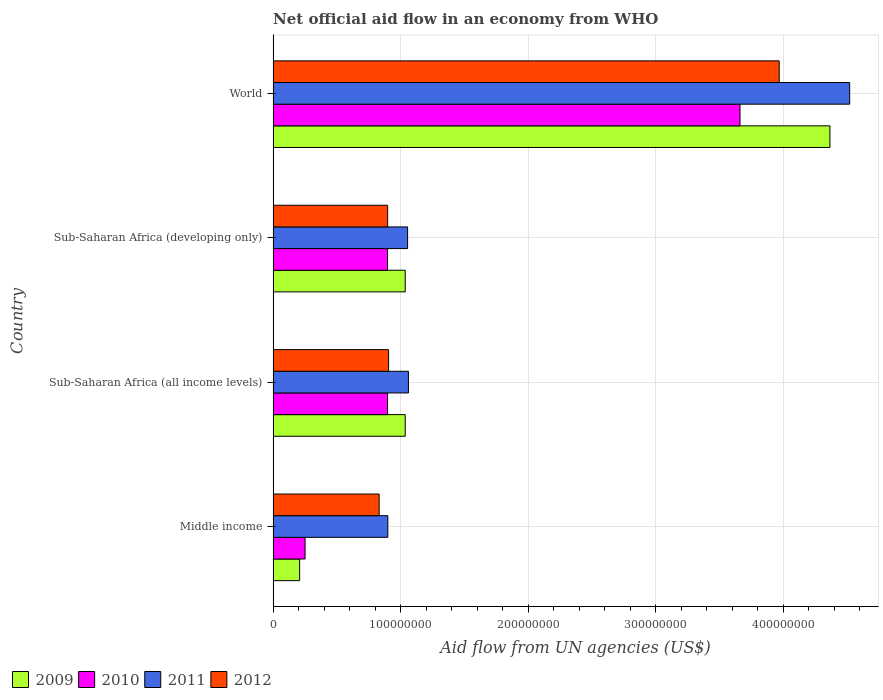How many groups of bars are there?
Ensure brevity in your answer.  4. How many bars are there on the 2nd tick from the top?
Make the answer very short. 4. What is the label of the 3rd group of bars from the top?
Your answer should be very brief. Sub-Saharan Africa (all income levels). What is the net official aid flow in 2010 in Sub-Saharan Africa (developing only)?
Your answer should be very brief. 8.98e+07. Across all countries, what is the maximum net official aid flow in 2010?
Provide a succinct answer. 3.66e+08. Across all countries, what is the minimum net official aid flow in 2011?
Make the answer very short. 9.00e+07. In which country was the net official aid flow in 2011 maximum?
Offer a terse response. World. In which country was the net official aid flow in 2011 minimum?
Provide a succinct answer. Middle income. What is the total net official aid flow in 2010 in the graph?
Offer a very short reply. 5.71e+08. What is the difference between the net official aid flow in 2009 in Sub-Saharan Africa (developing only) and that in World?
Ensure brevity in your answer.  -3.33e+08. What is the difference between the net official aid flow in 2010 in Sub-Saharan Africa (all income levels) and the net official aid flow in 2012 in Middle income?
Your answer should be compact. 6.58e+06. What is the average net official aid flow in 2009 per country?
Offer a very short reply. 1.66e+08. What is the difference between the net official aid flow in 2009 and net official aid flow in 2011 in Sub-Saharan Africa (all income levels)?
Your answer should be compact. -2.53e+06. Is the difference between the net official aid flow in 2009 in Sub-Saharan Africa (all income levels) and World greater than the difference between the net official aid flow in 2011 in Sub-Saharan Africa (all income levels) and World?
Provide a short and direct response. Yes. What is the difference between the highest and the second highest net official aid flow in 2011?
Provide a short and direct response. 3.46e+08. What is the difference between the highest and the lowest net official aid flow in 2009?
Keep it short and to the point. 4.16e+08. Is the sum of the net official aid flow in 2012 in Sub-Saharan Africa (all income levels) and World greater than the maximum net official aid flow in 2011 across all countries?
Make the answer very short. Yes. What does the 4th bar from the bottom in Sub-Saharan Africa (developing only) represents?
Give a very brief answer. 2012. Are all the bars in the graph horizontal?
Provide a short and direct response. Yes. How many countries are there in the graph?
Your answer should be very brief. 4. Where does the legend appear in the graph?
Offer a terse response. Bottom left. What is the title of the graph?
Ensure brevity in your answer.  Net official aid flow in an economy from WHO. Does "1964" appear as one of the legend labels in the graph?
Provide a short and direct response. No. What is the label or title of the X-axis?
Your answer should be very brief. Aid flow from UN agencies (US$). What is the Aid flow from UN agencies (US$) in 2009 in Middle income?
Keep it short and to the point. 2.08e+07. What is the Aid flow from UN agencies (US$) in 2010 in Middle income?
Your response must be concise. 2.51e+07. What is the Aid flow from UN agencies (US$) in 2011 in Middle income?
Provide a short and direct response. 9.00e+07. What is the Aid flow from UN agencies (US$) of 2012 in Middle income?
Your response must be concise. 8.32e+07. What is the Aid flow from UN agencies (US$) of 2009 in Sub-Saharan Africa (all income levels)?
Offer a terse response. 1.04e+08. What is the Aid flow from UN agencies (US$) in 2010 in Sub-Saharan Africa (all income levels)?
Give a very brief answer. 8.98e+07. What is the Aid flow from UN agencies (US$) in 2011 in Sub-Saharan Africa (all income levels)?
Your answer should be very brief. 1.06e+08. What is the Aid flow from UN agencies (US$) in 2012 in Sub-Saharan Africa (all income levels)?
Make the answer very short. 9.06e+07. What is the Aid flow from UN agencies (US$) in 2009 in Sub-Saharan Africa (developing only)?
Offer a very short reply. 1.04e+08. What is the Aid flow from UN agencies (US$) of 2010 in Sub-Saharan Africa (developing only)?
Provide a succinct answer. 8.98e+07. What is the Aid flow from UN agencies (US$) of 2011 in Sub-Saharan Africa (developing only)?
Your response must be concise. 1.05e+08. What is the Aid flow from UN agencies (US$) in 2012 in Sub-Saharan Africa (developing only)?
Your answer should be compact. 8.98e+07. What is the Aid flow from UN agencies (US$) of 2009 in World?
Your response must be concise. 4.37e+08. What is the Aid flow from UN agencies (US$) in 2010 in World?
Your answer should be compact. 3.66e+08. What is the Aid flow from UN agencies (US$) in 2011 in World?
Provide a succinct answer. 4.52e+08. What is the Aid flow from UN agencies (US$) in 2012 in World?
Offer a very short reply. 3.97e+08. Across all countries, what is the maximum Aid flow from UN agencies (US$) of 2009?
Provide a succinct answer. 4.37e+08. Across all countries, what is the maximum Aid flow from UN agencies (US$) of 2010?
Your answer should be compact. 3.66e+08. Across all countries, what is the maximum Aid flow from UN agencies (US$) of 2011?
Keep it short and to the point. 4.52e+08. Across all countries, what is the maximum Aid flow from UN agencies (US$) in 2012?
Ensure brevity in your answer.  3.97e+08. Across all countries, what is the minimum Aid flow from UN agencies (US$) in 2009?
Your answer should be compact. 2.08e+07. Across all countries, what is the minimum Aid flow from UN agencies (US$) in 2010?
Keep it short and to the point. 2.51e+07. Across all countries, what is the minimum Aid flow from UN agencies (US$) of 2011?
Provide a succinct answer. 9.00e+07. Across all countries, what is the minimum Aid flow from UN agencies (US$) in 2012?
Offer a terse response. 8.32e+07. What is the total Aid flow from UN agencies (US$) in 2009 in the graph?
Keep it short and to the point. 6.65e+08. What is the total Aid flow from UN agencies (US$) in 2010 in the graph?
Offer a terse response. 5.71e+08. What is the total Aid flow from UN agencies (US$) in 2011 in the graph?
Your answer should be compact. 7.54e+08. What is the total Aid flow from UN agencies (US$) of 2012 in the graph?
Provide a succinct answer. 6.61e+08. What is the difference between the Aid flow from UN agencies (US$) of 2009 in Middle income and that in Sub-Saharan Africa (all income levels)?
Offer a very short reply. -8.28e+07. What is the difference between the Aid flow from UN agencies (US$) of 2010 in Middle income and that in Sub-Saharan Africa (all income levels)?
Your answer should be very brief. -6.47e+07. What is the difference between the Aid flow from UN agencies (US$) of 2011 in Middle income and that in Sub-Saharan Africa (all income levels)?
Make the answer very short. -1.62e+07. What is the difference between the Aid flow from UN agencies (US$) of 2012 in Middle income and that in Sub-Saharan Africa (all income levels)?
Keep it short and to the point. -7.39e+06. What is the difference between the Aid flow from UN agencies (US$) in 2009 in Middle income and that in Sub-Saharan Africa (developing only)?
Offer a terse response. -8.28e+07. What is the difference between the Aid flow from UN agencies (US$) in 2010 in Middle income and that in Sub-Saharan Africa (developing only)?
Give a very brief answer. -6.47e+07. What is the difference between the Aid flow from UN agencies (US$) in 2011 in Middle income and that in Sub-Saharan Africa (developing only)?
Offer a very short reply. -1.55e+07. What is the difference between the Aid flow from UN agencies (US$) of 2012 in Middle income and that in Sub-Saharan Africa (developing only)?
Provide a short and direct response. -6.67e+06. What is the difference between the Aid flow from UN agencies (US$) in 2009 in Middle income and that in World?
Give a very brief answer. -4.16e+08. What is the difference between the Aid flow from UN agencies (US$) in 2010 in Middle income and that in World?
Provide a short and direct response. -3.41e+08. What is the difference between the Aid flow from UN agencies (US$) in 2011 in Middle income and that in World?
Your response must be concise. -3.62e+08. What is the difference between the Aid flow from UN agencies (US$) of 2012 in Middle income and that in World?
Offer a terse response. -3.14e+08. What is the difference between the Aid flow from UN agencies (US$) in 2010 in Sub-Saharan Africa (all income levels) and that in Sub-Saharan Africa (developing only)?
Offer a terse response. 0. What is the difference between the Aid flow from UN agencies (US$) of 2011 in Sub-Saharan Africa (all income levels) and that in Sub-Saharan Africa (developing only)?
Make the answer very short. 6.70e+05. What is the difference between the Aid flow from UN agencies (US$) of 2012 in Sub-Saharan Africa (all income levels) and that in Sub-Saharan Africa (developing only)?
Provide a short and direct response. 7.20e+05. What is the difference between the Aid flow from UN agencies (US$) of 2009 in Sub-Saharan Africa (all income levels) and that in World?
Offer a terse response. -3.33e+08. What is the difference between the Aid flow from UN agencies (US$) in 2010 in Sub-Saharan Africa (all income levels) and that in World?
Provide a succinct answer. -2.76e+08. What is the difference between the Aid flow from UN agencies (US$) in 2011 in Sub-Saharan Africa (all income levels) and that in World?
Provide a succinct answer. -3.46e+08. What is the difference between the Aid flow from UN agencies (US$) of 2012 in Sub-Saharan Africa (all income levels) and that in World?
Ensure brevity in your answer.  -3.06e+08. What is the difference between the Aid flow from UN agencies (US$) of 2009 in Sub-Saharan Africa (developing only) and that in World?
Offer a terse response. -3.33e+08. What is the difference between the Aid flow from UN agencies (US$) in 2010 in Sub-Saharan Africa (developing only) and that in World?
Provide a short and direct response. -2.76e+08. What is the difference between the Aid flow from UN agencies (US$) in 2011 in Sub-Saharan Africa (developing only) and that in World?
Your response must be concise. -3.47e+08. What is the difference between the Aid flow from UN agencies (US$) in 2012 in Sub-Saharan Africa (developing only) and that in World?
Provide a short and direct response. -3.07e+08. What is the difference between the Aid flow from UN agencies (US$) of 2009 in Middle income and the Aid flow from UN agencies (US$) of 2010 in Sub-Saharan Africa (all income levels)?
Provide a succinct answer. -6.90e+07. What is the difference between the Aid flow from UN agencies (US$) in 2009 in Middle income and the Aid flow from UN agencies (US$) in 2011 in Sub-Saharan Africa (all income levels)?
Ensure brevity in your answer.  -8.54e+07. What is the difference between the Aid flow from UN agencies (US$) in 2009 in Middle income and the Aid flow from UN agencies (US$) in 2012 in Sub-Saharan Africa (all income levels)?
Offer a very short reply. -6.98e+07. What is the difference between the Aid flow from UN agencies (US$) of 2010 in Middle income and the Aid flow from UN agencies (US$) of 2011 in Sub-Saharan Africa (all income levels)?
Offer a terse response. -8.11e+07. What is the difference between the Aid flow from UN agencies (US$) of 2010 in Middle income and the Aid flow from UN agencies (US$) of 2012 in Sub-Saharan Africa (all income levels)?
Ensure brevity in your answer.  -6.55e+07. What is the difference between the Aid flow from UN agencies (US$) of 2011 in Middle income and the Aid flow from UN agencies (US$) of 2012 in Sub-Saharan Africa (all income levels)?
Ensure brevity in your answer.  -5.90e+05. What is the difference between the Aid flow from UN agencies (US$) in 2009 in Middle income and the Aid flow from UN agencies (US$) in 2010 in Sub-Saharan Africa (developing only)?
Your answer should be very brief. -6.90e+07. What is the difference between the Aid flow from UN agencies (US$) of 2009 in Middle income and the Aid flow from UN agencies (US$) of 2011 in Sub-Saharan Africa (developing only)?
Offer a terse response. -8.47e+07. What is the difference between the Aid flow from UN agencies (US$) of 2009 in Middle income and the Aid flow from UN agencies (US$) of 2012 in Sub-Saharan Africa (developing only)?
Provide a succinct answer. -6.90e+07. What is the difference between the Aid flow from UN agencies (US$) of 2010 in Middle income and the Aid flow from UN agencies (US$) of 2011 in Sub-Saharan Africa (developing only)?
Your answer should be very brief. -8.04e+07. What is the difference between the Aid flow from UN agencies (US$) in 2010 in Middle income and the Aid flow from UN agencies (US$) in 2012 in Sub-Saharan Africa (developing only)?
Offer a terse response. -6.48e+07. What is the difference between the Aid flow from UN agencies (US$) of 2009 in Middle income and the Aid flow from UN agencies (US$) of 2010 in World?
Provide a short and direct response. -3.45e+08. What is the difference between the Aid flow from UN agencies (US$) of 2009 in Middle income and the Aid flow from UN agencies (US$) of 2011 in World?
Offer a very short reply. -4.31e+08. What is the difference between the Aid flow from UN agencies (US$) in 2009 in Middle income and the Aid flow from UN agencies (US$) in 2012 in World?
Provide a succinct answer. -3.76e+08. What is the difference between the Aid flow from UN agencies (US$) in 2010 in Middle income and the Aid flow from UN agencies (US$) in 2011 in World?
Your answer should be very brief. -4.27e+08. What is the difference between the Aid flow from UN agencies (US$) in 2010 in Middle income and the Aid flow from UN agencies (US$) in 2012 in World?
Your answer should be compact. -3.72e+08. What is the difference between the Aid flow from UN agencies (US$) in 2011 in Middle income and the Aid flow from UN agencies (US$) in 2012 in World?
Your response must be concise. -3.07e+08. What is the difference between the Aid flow from UN agencies (US$) in 2009 in Sub-Saharan Africa (all income levels) and the Aid flow from UN agencies (US$) in 2010 in Sub-Saharan Africa (developing only)?
Give a very brief answer. 1.39e+07. What is the difference between the Aid flow from UN agencies (US$) in 2009 in Sub-Saharan Africa (all income levels) and the Aid flow from UN agencies (US$) in 2011 in Sub-Saharan Africa (developing only)?
Provide a succinct answer. -1.86e+06. What is the difference between the Aid flow from UN agencies (US$) of 2009 in Sub-Saharan Africa (all income levels) and the Aid flow from UN agencies (US$) of 2012 in Sub-Saharan Africa (developing only)?
Provide a succinct answer. 1.38e+07. What is the difference between the Aid flow from UN agencies (US$) of 2010 in Sub-Saharan Africa (all income levels) and the Aid flow from UN agencies (US$) of 2011 in Sub-Saharan Africa (developing only)?
Give a very brief answer. -1.57e+07. What is the difference between the Aid flow from UN agencies (US$) in 2011 in Sub-Saharan Africa (all income levels) and the Aid flow from UN agencies (US$) in 2012 in Sub-Saharan Africa (developing only)?
Offer a terse response. 1.63e+07. What is the difference between the Aid flow from UN agencies (US$) of 2009 in Sub-Saharan Africa (all income levels) and the Aid flow from UN agencies (US$) of 2010 in World?
Your answer should be very brief. -2.63e+08. What is the difference between the Aid flow from UN agencies (US$) in 2009 in Sub-Saharan Africa (all income levels) and the Aid flow from UN agencies (US$) in 2011 in World?
Offer a terse response. -3.49e+08. What is the difference between the Aid flow from UN agencies (US$) of 2009 in Sub-Saharan Africa (all income levels) and the Aid flow from UN agencies (US$) of 2012 in World?
Keep it short and to the point. -2.93e+08. What is the difference between the Aid flow from UN agencies (US$) of 2010 in Sub-Saharan Africa (all income levels) and the Aid flow from UN agencies (US$) of 2011 in World?
Keep it short and to the point. -3.62e+08. What is the difference between the Aid flow from UN agencies (US$) in 2010 in Sub-Saharan Africa (all income levels) and the Aid flow from UN agencies (US$) in 2012 in World?
Offer a terse response. -3.07e+08. What is the difference between the Aid flow from UN agencies (US$) in 2011 in Sub-Saharan Africa (all income levels) and the Aid flow from UN agencies (US$) in 2012 in World?
Give a very brief answer. -2.91e+08. What is the difference between the Aid flow from UN agencies (US$) in 2009 in Sub-Saharan Africa (developing only) and the Aid flow from UN agencies (US$) in 2010 in World?
Offer a very short reply. -2.63e+08. What is the difference between the Aid flow from UN agencies (US$) of 2009 in Sub-Saharan Africa (developing only) and the Aid flow from UN agencies (US$) of 2011 in World?
Make the answer very short. -3.49e+08. What is the difference between the Aid flow from UN agencies (US$) of 2009 in Sub-Saharan Africa (developing only) and the Aid flow from UN agencies (US$) of 2012 in World?
Offer a very short reply. -2.93e+08. What is the difference between the Aid flow from UN agencies (US$) of 2010 in Sub-Saharan Africa (developing only) and the Aid flow from UN agencies (US$) of 2011 in World?
Ensure brevity in your answer.  -3.62e+08. What is the difference between the Aid flow from UN agencies (US$) of 2010 in Sub-Saharan Africa (developing only) and the Aid flow from UN agencies (US$) of 2012 in World?
Give a very brief answer. -3.07e+08. What is the difference between the Aid flow from UN agencies (US$) of 2011 in Sub-Saharan Africa (developing only) and the Aid flow from UN agencies (US$) of 2012 in World?
Your response must be concise. -2.92e+08. What is the average Aid flow from UN agencies (US$) in 2009 per country?
Offer a terse response. 1.66e+08. What is the average Aid flow from UN agencies (US$) of 2010 per country?
Offer a very short reply. 1.43e+08. What is the average Aid flow from UN agencies (US$) of 2011 per country?
Offer a very short reply. 1.88e+08. What is the average Aid flow from UN agencies (US$) of 2012 per country?
Provide a succinct answer. 1.65e+08. What is the difference between the Aid flow from UN agencies (US$) in 2009 and Aid flow from UN agencies (US$) in 2010 in Middle income?
Make the answer very short. -4.27e+06. What is the difference between the Aid flow from UN agencies (US$) of 2009 and Aid flow from UN agencies (US$) of 2011 in Middle income?
Your answer should be very brief. -6.92e+07. What is the difference between the Aid flow from UN agencies (US$) of 2009 and Aid flow from UN agencies (US$) of 2012 in Middle income?
Provide a succinct answer. -6.24e+07. What is the difference between the Aid flow from UN agencies (US$) of 2010 and Aid flow from UN agencies (US$) of 2011 in Middle income?
Give a very brief answer. -6.49e+07. What is the difference between the Aid flow from UN agencies (US$) of 2010 and Aid flow from UN agencies (US$) of 2012 in Middle income?
Your answer should be compact. -5.81e+07. What is the difference between the Aid flow from UN agencies (US$) of 2011 and Aid flow from UN agencies (US$) of 2012 in Middle income?
Keep it short and to the point. 6.80e+06. What is the difference between the Aid flow from UN agencies (US$) in 2009 and Aid flow from UN agencies (US$) in 2010 in Sub-Saharan Africa (all income levels)?
Your answer should be compact. 1.39e+07. What is the difference between the Aid flow from UN agencies (US$) in 2009 and Aid flow from UN agencies (US$) in 2011 in Sub-Saharan Africa (all income levels)?
Keep it short and to the point. -2.53e+06. What is the difference between the Aid flow from UN agencies (US$) of 2009 and Aid flow from UN agencies (US$) of 2012 in Sub-Saharan Africa (all income levels)?
Your answer should be very brief. 1.30e+07. What is the difference between the Aid flow from UN agencies (US$) in 2010 and Aid flow from UN agencies (US$) in 2011 in Sub-Saharan Africa (all income levels)?
Your answer should be very brief. -1.64e+07. What is the difference between the Aid flow from UN agencies (US$) of 2010 and Aid flow from UN agencies (US$) of 2012 in Sub-Saharan Africa (all income levels)?
Make the answer very short. -8.10e+05. What is the difference between the Aid flow from UN agencies (US$) in 2011 and Aid flow from UN agencies (US$) in 2012 in Sub-Saharan Africa (all income levels)?
Provide a succinct answer. 1.56e+07. What is the difference between the Aid flow from UN agencies (US$) in 2009 and Aid flow from UN agencies (US$) in 2010 in Sub-Saharan Africa (developing only)?
Keep it short and to the point. 1.39e+07. What is the difference between the Aid flow from UN agencies (US$) in 2009 and Aid flow from UN agencies (US$) in 2011 in Sub-Saharan Africa (developing only)?
Your answer should be compact. -1.86e+06. What is the difference between the Aid flow from UN agencies (US$) in 2009 and Aid flow from UN agencies (US$) in 2012 in Sub-Saharan Africa (developing only)?
Offer a terse response. 1.38e+07. What is the difference between the Aid flow from UN agencies (US$) in 2010 and Aid flow from UN agencies (US$) in 2011 in Sub-Saharan Africa (developing only)?
Ensure brevity in your answer.  -1.57e+07. What is the difference between the Aid flow from UN agencies (US$) of 2010 and Aid flow from UN agencies (US$) of 2012 in Sub-Saharan Africa (developing only)?
Your answer should be compact. -9.00e+04. What is the difference between the Aid flow from UN agencies (US$) of 2011 and Aid flow from UN agencies (US$) of 2012 in Sub-Saharan Africa (developing only)?
Your answer should be very brief. 1.56e+07. What is the difference between the Aid flow from UN agencies (US$) of 2009 and Aid flow from UN agencies (US$) of 2010 in World?
Your answer should be compact. 7.06e+07. What is the difference between the Aid flow from UN agencies (US$) of 2009 and Aid flow from UN agencies (US$) of 2011 in World?
Offer a terse response. -1.55e+07. What is the difference between the Aid flow from UN agencies (US$) in 2009 and Aid flow from UN agencies (US$) in 2012 in World?
Provide a short and direct response. 3.98e+07. What is the difference between the Aid flow from UN agencies (US$) in 2010 and Aid flow from UN agencies (US$) in 2011 in World?
Ensure brevity in your answer.  -8.60e+07. What is the difference between the Aid flow from UN agencies (US$) of 2010 and Aid flow from UN agencies (US$) of 2012 in World?
Offer a terse response. -3.08e+07. What is the difference between the Aid flow from UN agencies (US$) of 2011 and Aid flow from UN agencies (US$) of 2012 in World?
Keep it short and to the point. 5.53e+07. What is the ratio of the Aid flow from UN agencies (US$) in 2009 in Middle income to that in Sub-Saharan Africa (all income levels)?
Your answer should be very brief. 0.2. What is the ratio of the Aid flow from UN agencies (US$) in 2010 in Middle income to that in Sub-Saharan Africa (all income levels)?
Offer a terse response. 0.28. What is the ratio of the Aid flow from UN agencies (US$) in 2011 in Middle income to that in Sub-Saharan Africa (all income levels)?
Give a very brief answer. 0.85. What is the ratio of the Aid flow from UN agencies (US$) of 2012 in Middle income to that in Sub-Saharan Africa (all income levels)?
Provide a succinct answer. 0.92. What is the ratio of the Aid flow from UN agencies (US$) of 2009 in Middle income to that in Sub-Saharan Africa (developing only)?
Keep it short and to the point. 0.2. What is the ratio of the Aid flow from UN agencies (US$) in 2010 in Middle income to that in Sub-Saharan Africa (developing only)?
Your answer should be very brief. 0.28. What is the ratio of the Aid flow from UN agencies (US$) of 2011 in Middle income to that in Sub-Saharan Africa (developing only)?
Keep it short and to the point. 0.85. What is the ratio of the Aid flow from UN agencies (US$) of 2012 in Middle income to that in Sub-Saharan Africa (developing only)?
Offer a very short reply. 0.93. What is the ratio of the Aid flow from UN agencies (US$) in 2009 in Middle income to that in World?
Your answer should be very brief. 0.05. What is the ratio of the Aid flow from UN agencies (US$) of 2010 in Middle income to that in World?
Make the answer very short. 0.07. What is the ratio of the Aid flow from UN agencies (US$) in 2011 in Middle income to that in World?
Your answer should be very brief. 0.2. What is the ratio of the Aid flow from UN agencies (US$) of 2012 in Middle income to that in World?
Your answer should be very brief. 0.21. What is the ratio of the Aid flow from UN agencies (US$) of 2009 in Sub-Saharan Africa (all income levels) to that in Sub-Saharan Africa (developing only)?
Offer a very short reply. 1. What is the ratio of the Aid flow from UN agencies (US$) in 2010 in Sub-Saharan Africa (all income levels) to that in Sub-Saharan Africa (developing only)?
Provide a succinct answer. 1. What is the ratio of the Aid flow from UN agencies (US$) in 2011 in Sub-Saharan Africa (all income levels) to that in Sub-Saharan Africa (developing only)?
Your answer should be compact. 1.01. What is the ratio of the Aid flow from UN agencies (US$) of 2012 in Sub-Saharan Africa (all income levels) to that in Sub-Saharan Africa (developing only)?
Ensure brevity in your answer.  1.01. What is the ratio of the Aid flow from UN agencies (US$) in 2009 in Sub-Saharan Africa (all income levels) to that in World?
Your response must be concise. 0.24. What is the ratio of the Aid flow from UN agencies (US$) of 2010 in Sub-Saharan Africa (all income levels) to that in World?
Your answer should be compact. 0.25. What is the ratio of the Aid flow from UN agencies (US$) of 2011 in Sub-Saharan Africa (all income levels) to that in World?
Offer a very short reply. 0.23. What is the ratio of the Aid flow from UN agencies (US$) in 2012 in Sub-Saharan Africa (all income levels) to that in World?
Your answer should be very brief. 0.23. What is the ratio of the Aid flow from UN agencies (US$) of 2009 in Sub-Saharan Africa (developing only) to that in World?
Ensure brevity in your answer.  0.24. What is the ratio of the Aid flow from UN agencies (US$) of 2010 in Sub-Saharan Africa (developing only) to that in World?
Offer a terse response. 0.25. What is the ratio of the Aid flow from UN agencies (US$) of 2011 in Sub-Saharan Africa (developing only) to that in World?
Provide a succinct answer. 0.23. What is the ratio of the Aid flow from UN agencies (US$) of 2012 in Sub-Saharan Africa (developing only) to that in World?
Keep it short and to the point. 0.23. What is the difference between the highest and the second highest Aid flow from UN agencies (US$) in 2009?
Make the answer very short. 3.33e+08. What is the difference between the highest and the second highest Aid flow from UN agencies (US$) in 2010?
Provide a short and direct response. 2.76e+08. What is the difference between the highest and the second highest Aid flow from UN agencies (US$) in 2011?
Make the answer very short. 3.46e+08. What is the difference between the highest and the second highest Aid flow from UN agencies (US$) in 2012?
Ensure brevity in your answer.  3.06e+08. What is the difference between the highest and the lowest Aid flow from UN agencies (US$) of 2009?
Your response must be concise. 4.16e+08. What is the difference between the highest and the lowest Aid flow from UN agencies (US$) in 2010?
Offer a terse response. 3.41e+08. What is the difference between the highest and the lowest Aid flow from UN agencies (US$) of 2011?
Offer a terse response. 3.62e+08. What is the difference between the highest and the lowest Aid flow from UN agencies (US$) in 2012?
Your answer should be compact. 3.14e+08. 